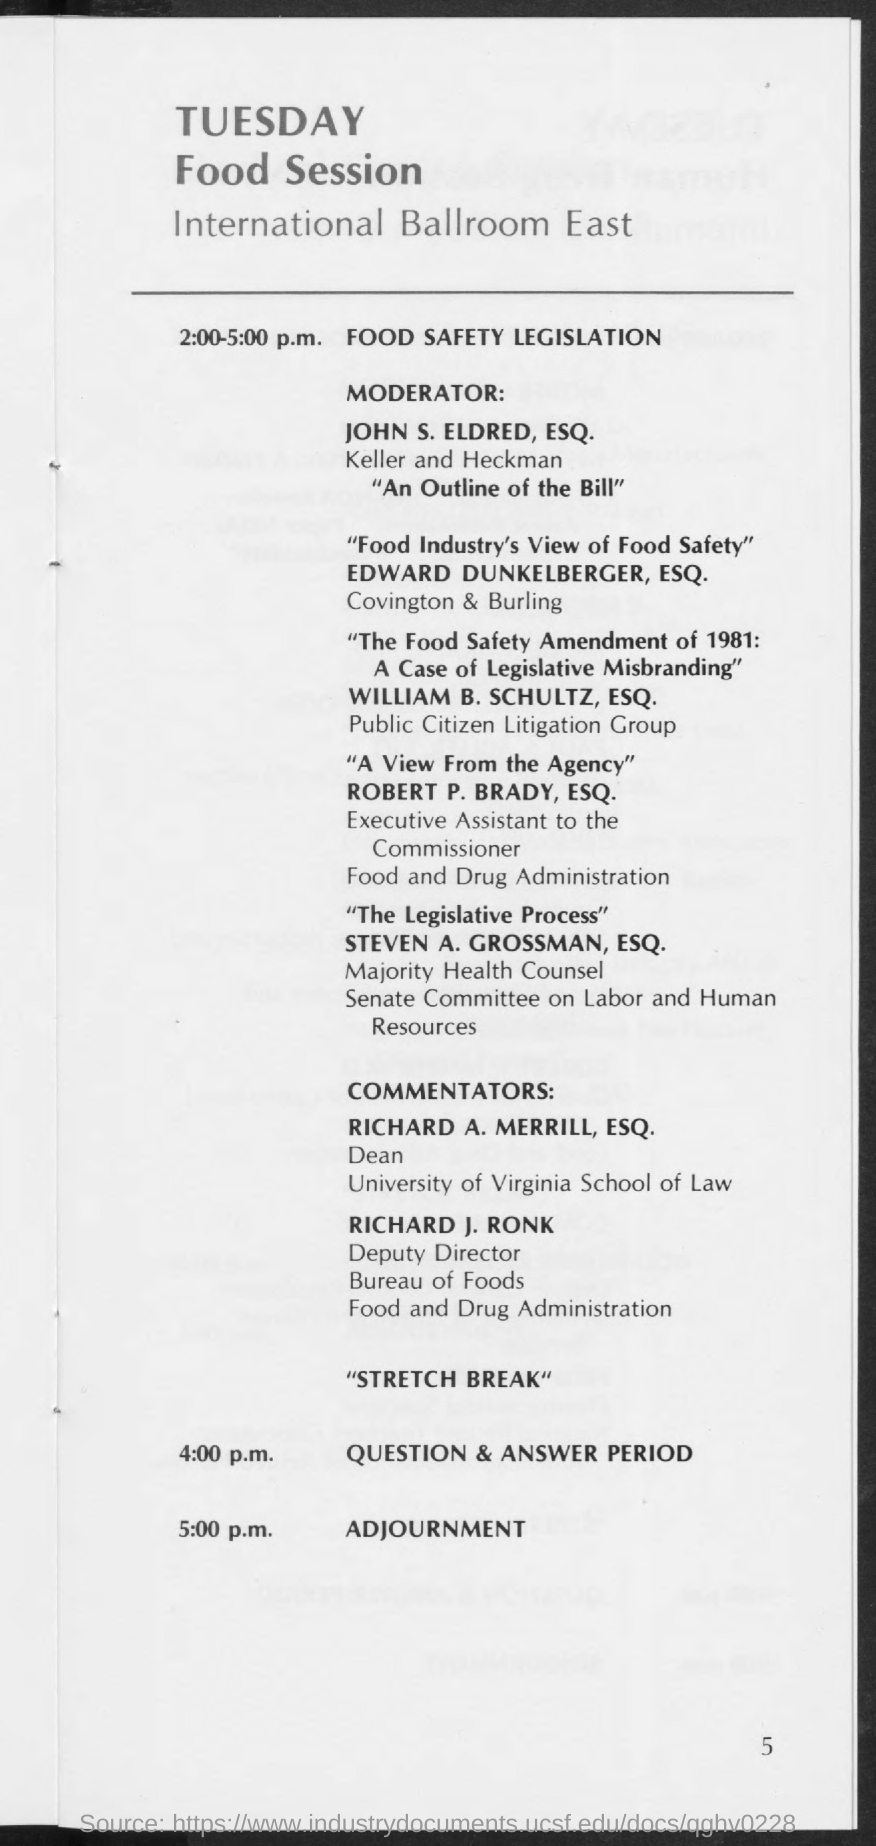Draw attention to some important aspects in this diagram. The Food Sessions are adjourned at 5:00 p.m. It has been announced that Edward Dunkelberger, Esq. will be presenting the session on "Food Industry's View of Food Safety". Robert P. Brady, Esq. holds the designation of Executive Assistant to the Commissioner. John S. Eldred, Esquire, is the moderator for Food Safety Legislation. The question and answer session will be held at 4:00 p.m. 